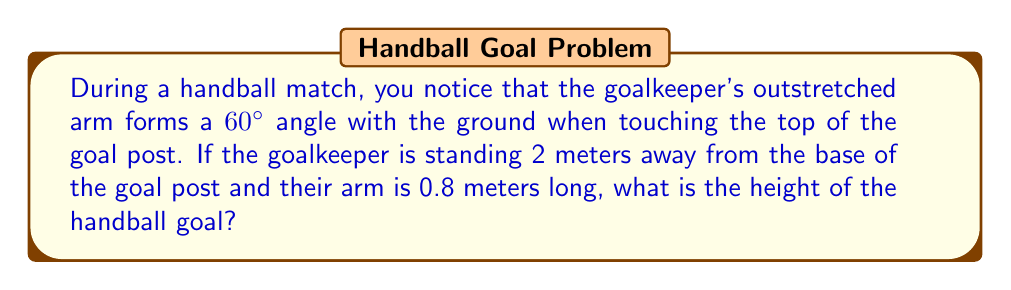Can you answer this question? Let's approach this step-by-step using trigonometry:

1) We can visualize this scenario as a right-angled triangle, where:
   - The goal post is the vertical side (height we want to find)
   - The distance from the goalkeeper to the goal post is the horizontal side (2 meters)
   - The goalkeeper's arm is the hypotenuse (0.8 meters)

2) We know that the angle between the ground and the goalkeeper's arm is 60°.

3) In this right-angled triangle, we can use the tangent ratio:

   $$\tan \theta = \frac{\text{opposite}}{\text{adjacent}}$$

4) Here, $\theta = 60°$, the opposite side is the height of the goal (h), and the adjacent side is 2 meters:

   $$\tan 60° = \frac{h}{2}$$

5) We know that $\tan 60° = \sqrt{3}$, so:

   $$\sqrt{3} = \frac{h}{2}$$

6) Solving for h:

   $$h = 2\sqrt{3}$$

7) To get a decimal approximation:

   $$h \approx 2 * 1.732 \approx 3.464 \text{ meters}$$

8) However, this is the height from the ground to the goalkeeper's hand. To get the actual goal height, we need to subtract the distance between the goalkeeper's hand and the top of the goal.

9) We can find this using the Pythagorean theorem:

   $$a^2 + b^2 = c^2$$
   $$a^2 + 2^2 = 0.8^2$$
   $$a^2 = 0.64 - 4 = -3.36$$
   $$a = \sqrt{3.36} \approx 1.833 \text{ meters}$$

10) Therefore, the actual goal height is:

    $$3.464 - 1.833 = 1.631 \text{ meters}$$

This is very close to the official handball goal height of 2 meters, with the difference likely due to rounding and the goalkeeper's exact position.
Answer: $1.631$ meters 